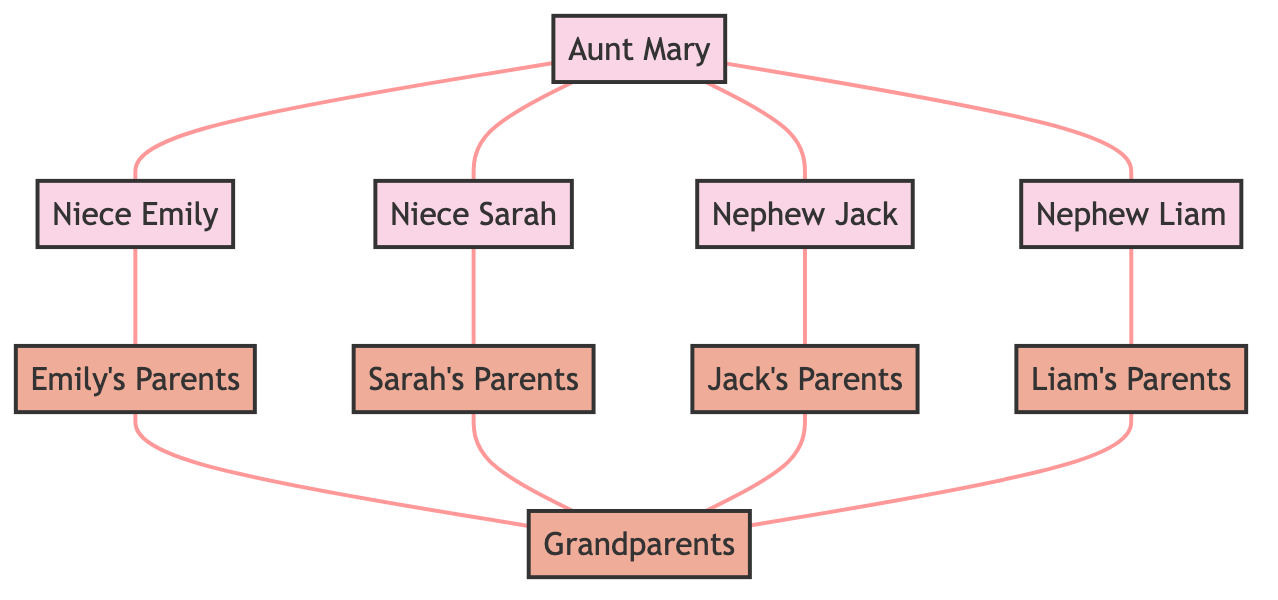What role does Aunt Mary possess in this diagram? Aunt Mary is identified as "Aunt" in the diagram, as indicated by the node's role attribute.
Answer: Aunt How many nieces does Aunt Mary have? The diagram shows two edges connecting Aunt Mary to Niece Emily and Niece Sarah, meaning she has two nieces.
Answer: 2 Which nephew is directly connected to Aunt Mary? The diagram displays two edges from Aunt Mary to Nephew Jack and Nephew Liam, therefore both nephews are directly connected to her.
Answer: Jack and Liam What relationship does Niece Emily have with her parents? The diagram depicts an edge between Niece Emily and her parents, labeled as "Child-Parent," denoting that Emily is a child of her parents.
Answer: Child-Parent How many family groups are represented in the diagram? The diagram includes four family groups: Emily's Parents, Sarah's Parents, Jack's Parents, and Liam's Parents, in addition to Grandparents, making a total of five family groups.
Answer: 5 What is the number of edges connecting the grandparents to the parents? Each of the four family groups has an edge connecting them to Grandparents, leading to a total of four edges.
Answer: 4 Which node connects Niece Sarah to her parents? The edge in the diagram indicates that Niece Sarah connects to Sarah's Parents, directly representing their relationship.
Answer: Sarah's Parents How many individuals are represented in this diagram? The diagram includes four nieces/nephews (Emily, Sarah, Jack, Liam) and one aunt (Mary), making it a total of five individuals.
Answer: 5 Are there any parents that connect to both Aunt Mary’s nieces and nephews? The diagram shows that all children (Niece Emily, Niece Sarah, Nephew Jack, Nephew Liam) have individual connections to their respective parents, who connect indirectly through connections in the family.
Answer: Yes, Grandparents 